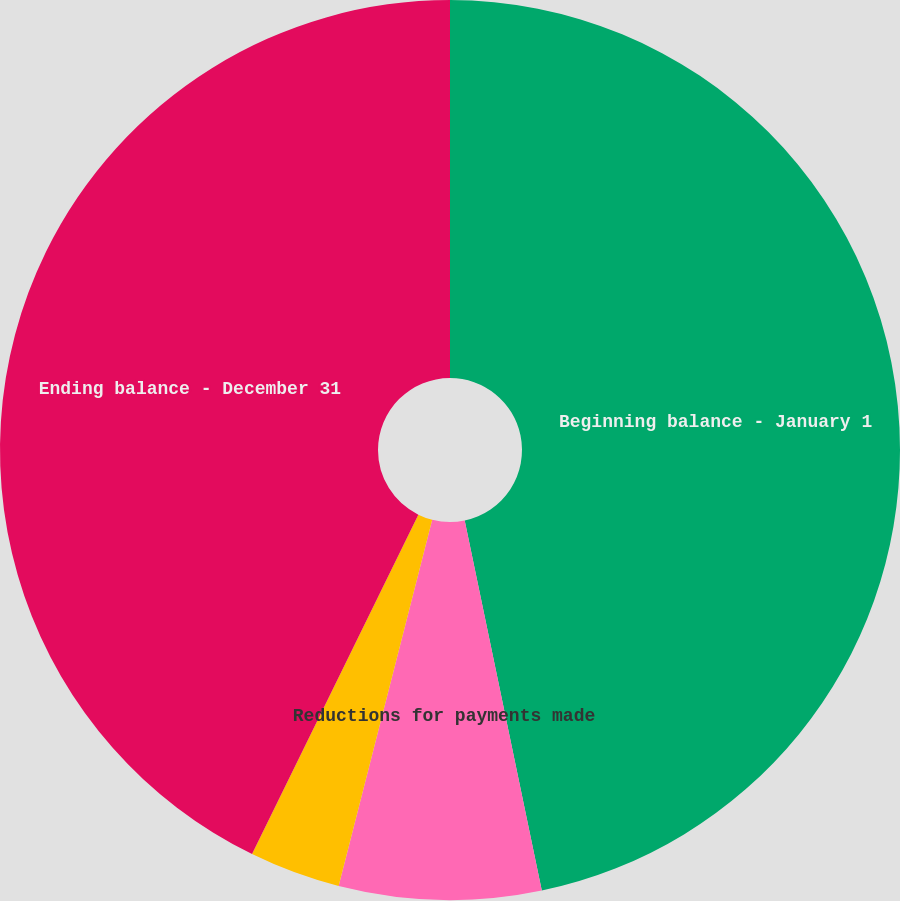Convert chart to OTSL. <chart><loc_0><loc_0><loc_500><loc_500><pie_chart><fcel>Beginning balance - January 1<fcel>Reductions for payments made<fcel>Changes in estimates<fcel>Ending balance - December 31<nl><fcel>46.73%<fcel>7.25%<fcel>3.27%<fcel>42.75%<nl></chart> 